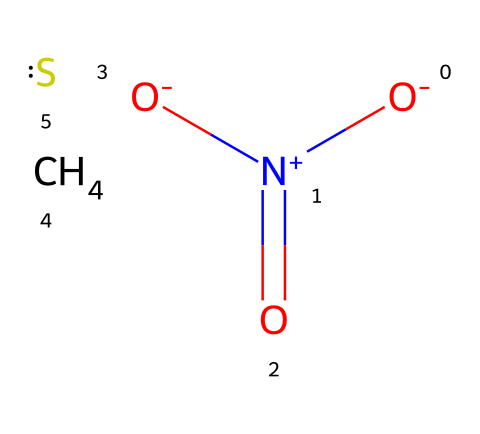What is the molecular formula of the compound represented? The provided SMILES indicates the presence of one carbon atom, one sulfur atom, and four oxygen atoms, along with one nitrogen atom. From this analysis, the molecular formula is CSSO4N.
Answer: CSSO4N How many total atoms are present in the compound? By counting the individual atoms in the molecular formula (C=1, S=1, O=4, N=1), we find a total of 7 atoms.
Answer: 7 What type of chemical reaction occurs when this compound combusts? Combustion reactions typically involve the reaction of a substance with oxygen, resulting in heat and light, often producing carbon dioxide and water as byproducts. The presence of oxygen and nitrogen suggests this is an explosive combustion reaction.
Answer: explosive What is the role of the nitrogen in the combustion process? Nitrogen in gunpowder is part of the oxidizing agent, which helps to release energy during combustion. It aids in producing gas and heat rapidly.
Answer: oxidizer What is the primary product of the combustion of this compound? The main product of gunpowder combustion is carbon dioxide along with nitrogen gas and sulfur dioxide.
Answer: carbon dioxide Which functional groups are present in this chemical composition? The compound contains a nitro group from the nitro groups indicated by [N+](=O)[O-] and thiol from sulfur. These contribute to its explosive properties.
Answer: nitro and thiol 